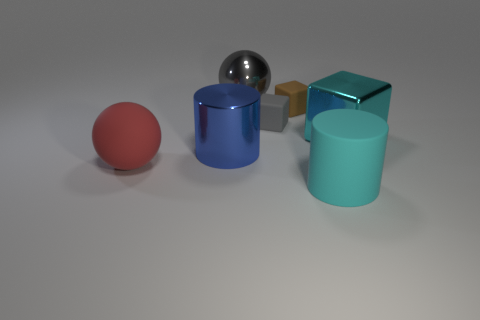Do the red rubber thing and the large rubber object that is in front of the red ball have the same shape? no 